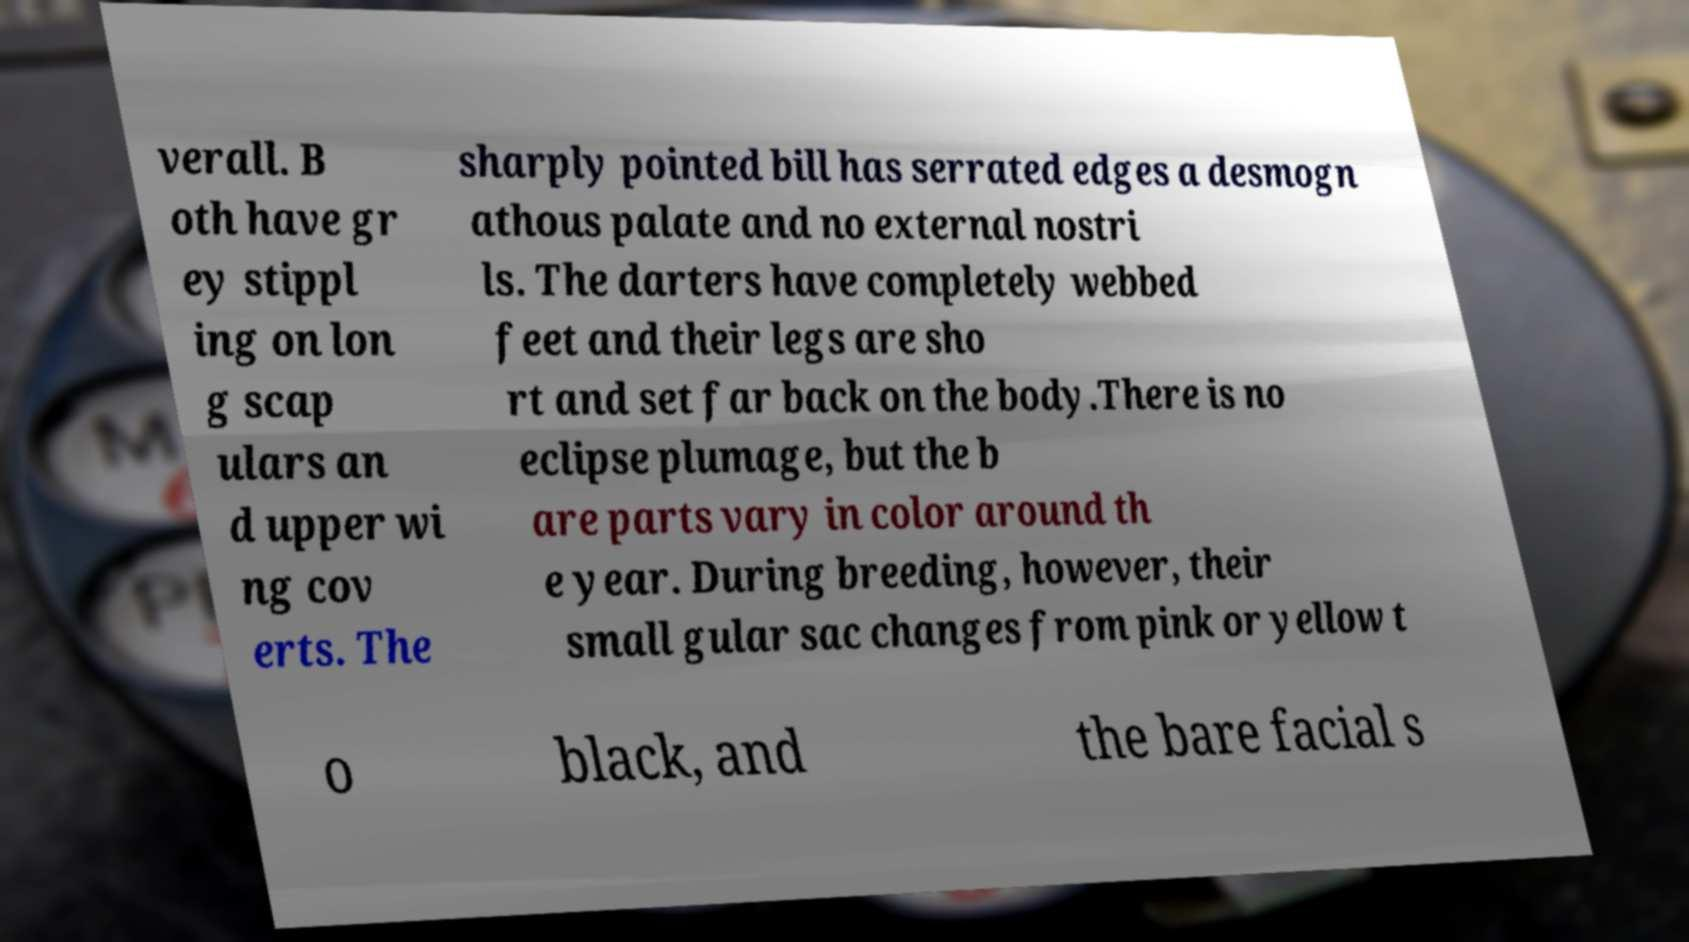I need the written content from this picture converted into text. Can you do that? verall. B oth have gr ey stippl ing on lon g scap ulars an d upper wi ng cov erts. The sharply pointed bill has serrated edges a desmogn athous palate and no external nostri ls. The darters have completely webbed feet and their legs are sho rt and set far back on the body.There is no eclipse plumage, but the b are parts vary in color around th e year. During breeding, however, their small gular sac changes from pink or yellow t o black, and the bare facial s 